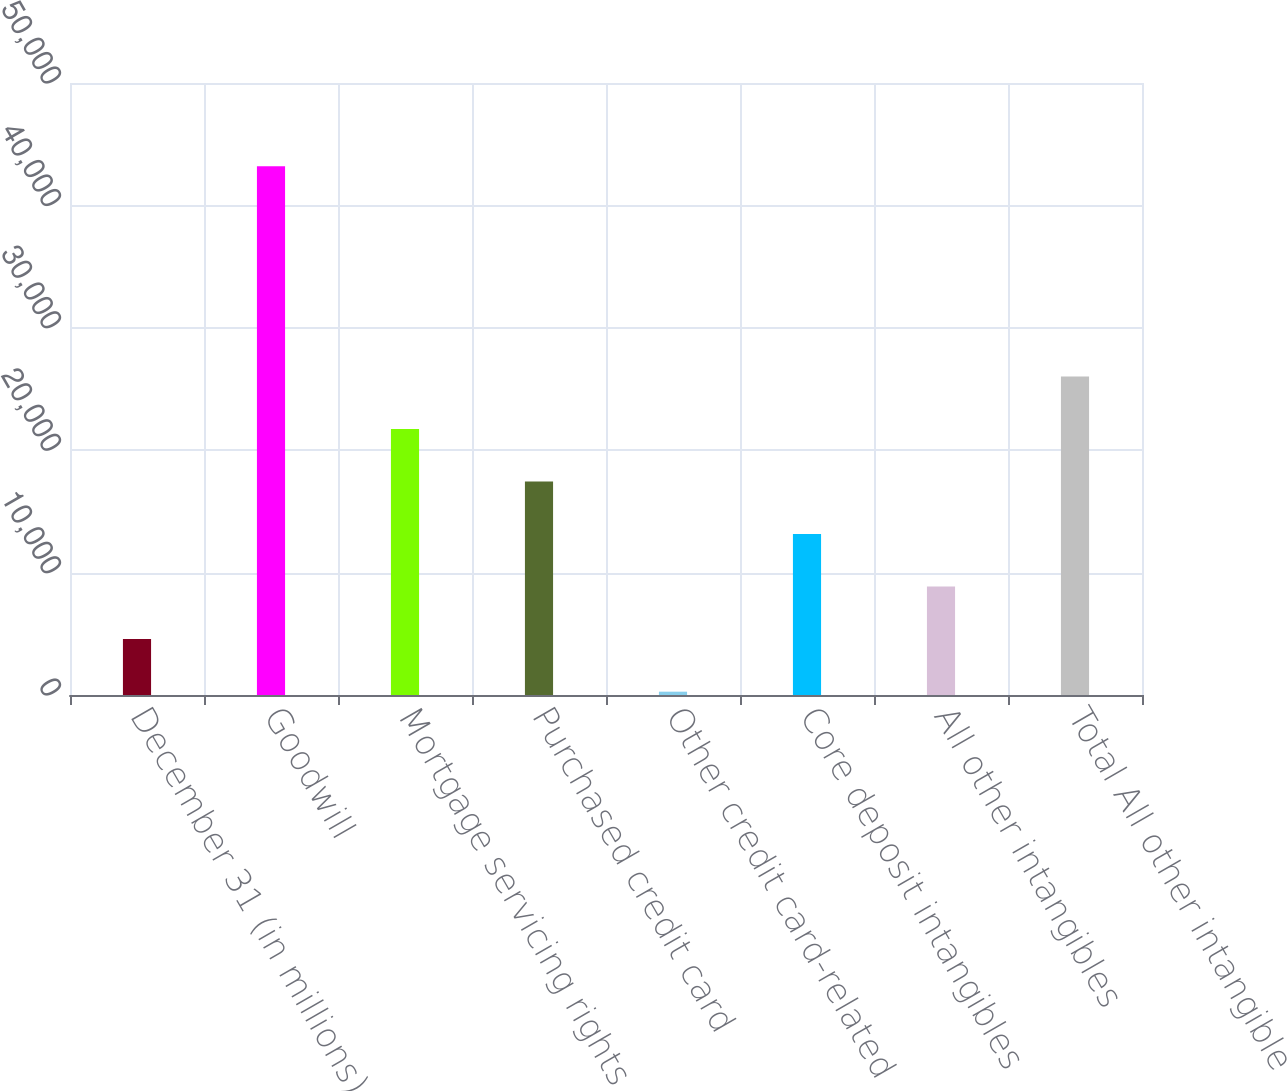<chart> <loc_0><loc_0><loc_500><loc_500><bar_chart><fcel>December 31 (in millions)<fcel>Goodwill<fcel>Mortgage servicing rights<fcel>Purchased credit card<fcel>Other credit card-related<fcel>Core deposit intangibles<fcel>All other intangibles<fcel>Total All other intangible<nl><fcel>4565.1<fcel>43203<fcel>21737.5<fcel>17444.4<fcel>272<fcel>13151.3<fcel>8858.2<fcel>26030.6<nl></chart> 